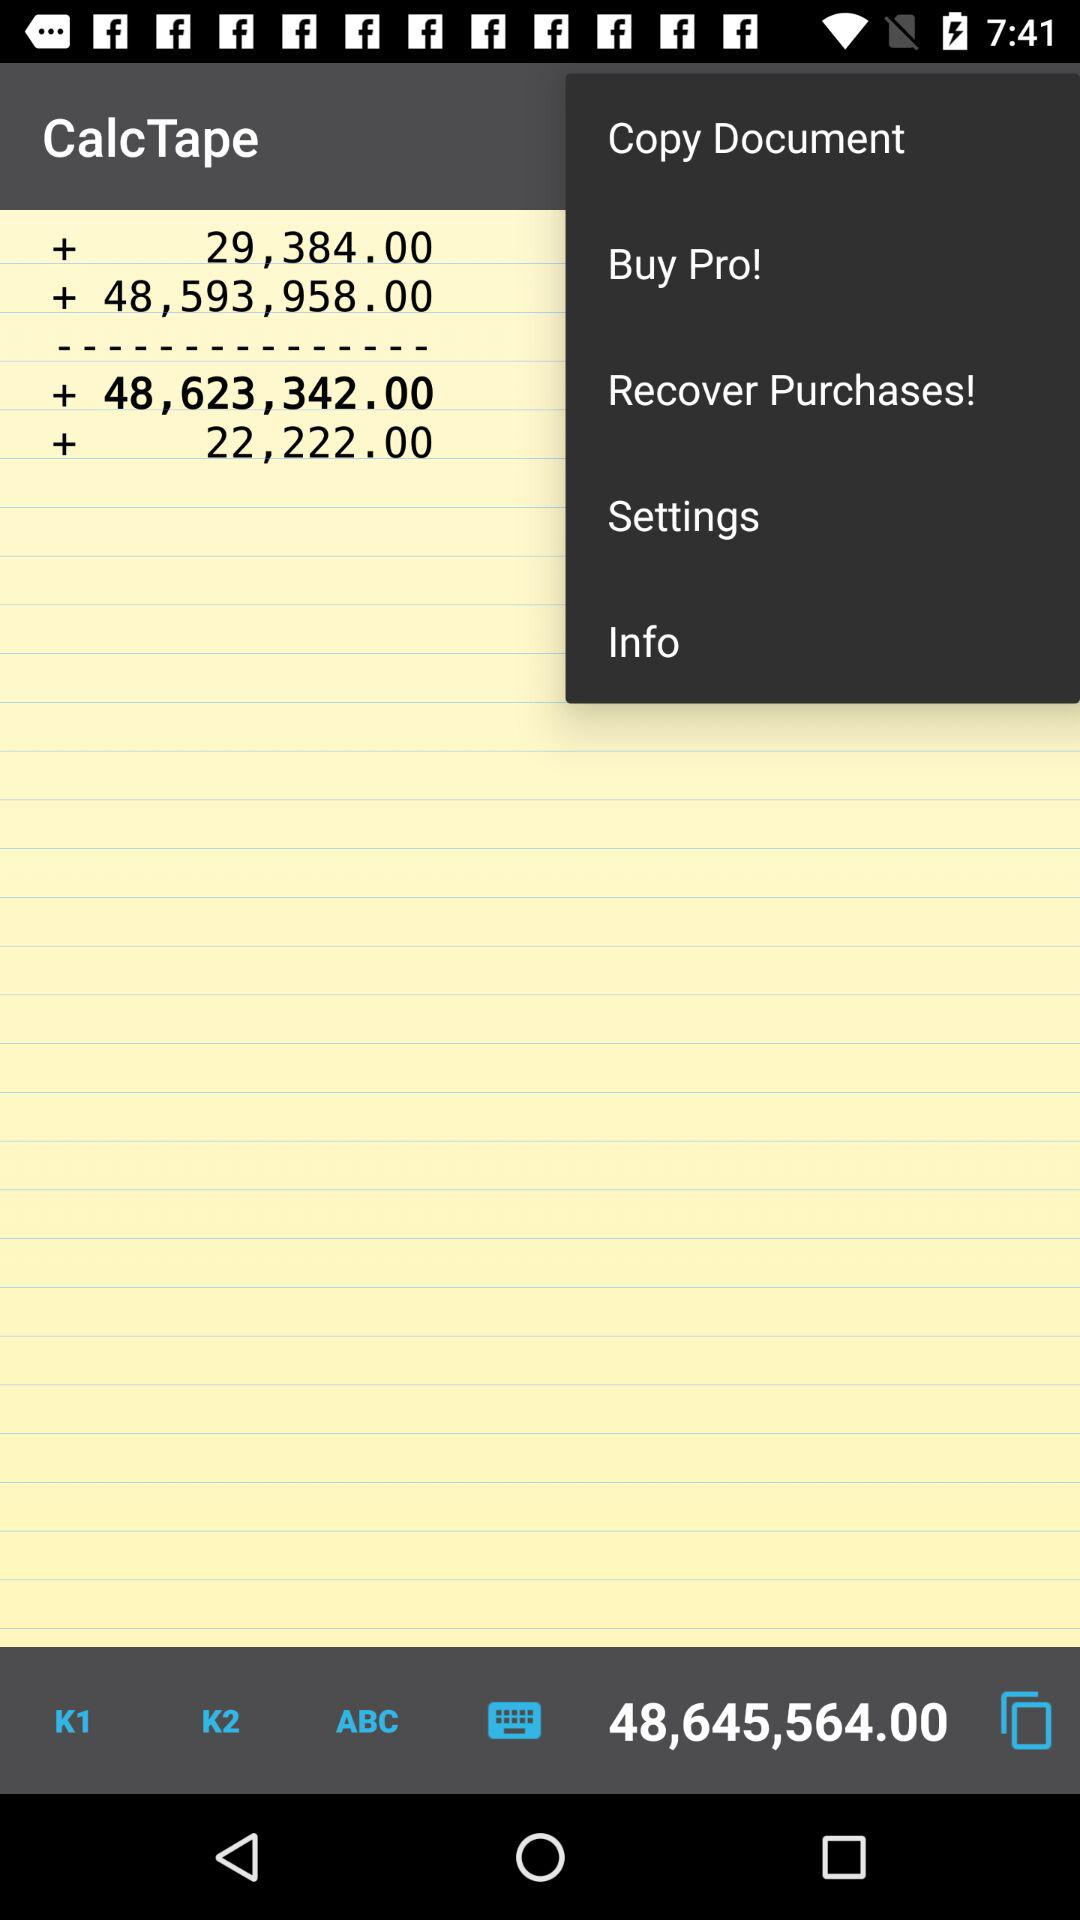What is the sum? The sum is 48,645,564.00. 